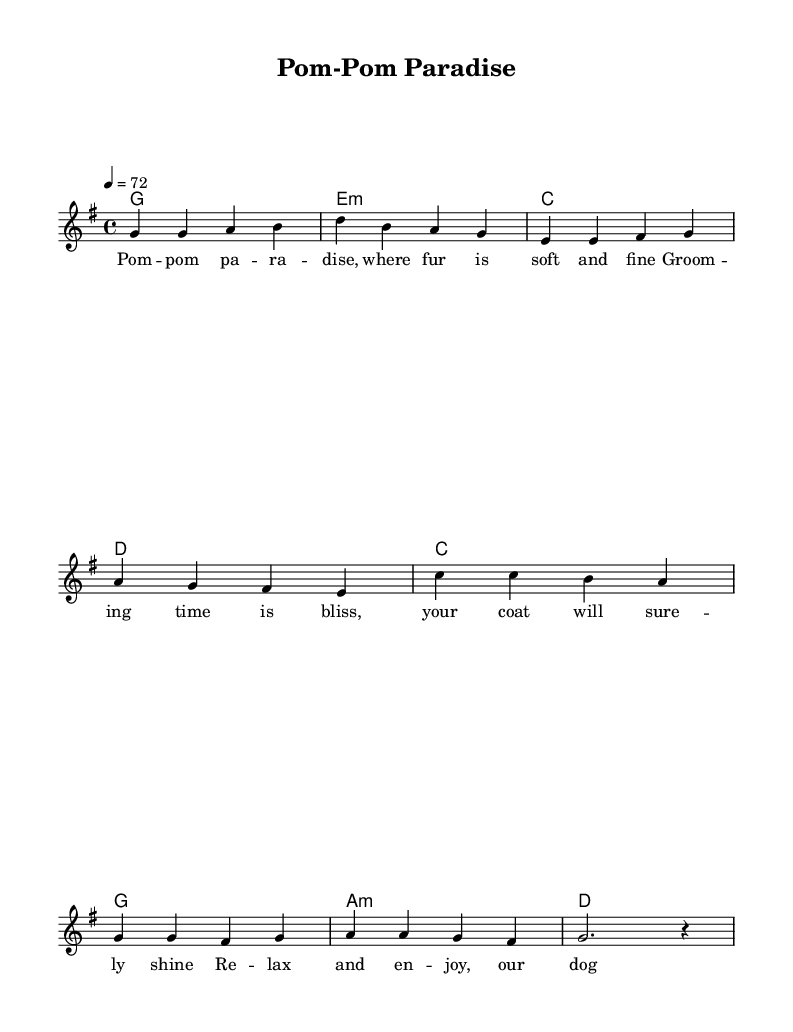What is the key signature of this music? The key signature is G major, which has one sharp (F#). This can be identified by looking at the signature at the beginning of the staff.
Answer: G major What is the time signature of the piece? The time signature is 4/4, which can be seen at the beginning of the score. It indicates that there are four beats in each measure and a quarter note receives one beat.
Answer: 4/4 What is the tempo marking for this piece? The tempo marking is specified as quarter note equals 72 (4 = 72), indicating a medium, relaxed speed. This is typically seen at the start of the score.
Answer: 72 How many measures are in the verse of the song? The verse contains a total of 4 measures, as counted from the notation provided in the melody section.
Answer: 4 What chord does the piece start with? The piece begins with the G major chord, indicated by the chord name at the start of the chord progression in the first measure.
Answer: G What is the thematic focus of the lyrics? The thematic focus of the lyrics centers on dog grooming and relaxation, as seen throughout the text that emphasizes grooming time and spa days for dogs.
Answer: Dog grooming In what genre is this music categorized? The music is categorized as reggae, which can be deduced from the relaxed style and rhythmic structure typical of reggae music.
Answer: Reggae 